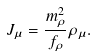Convert formula to latex. <formula><loc_0><loc_0><loc_500><loc_500>J _ { \mu } = \frac { m _ { \rho } ^ { 2 } } { f _ { \rho } } \rho _ { \mu } .</formula> 